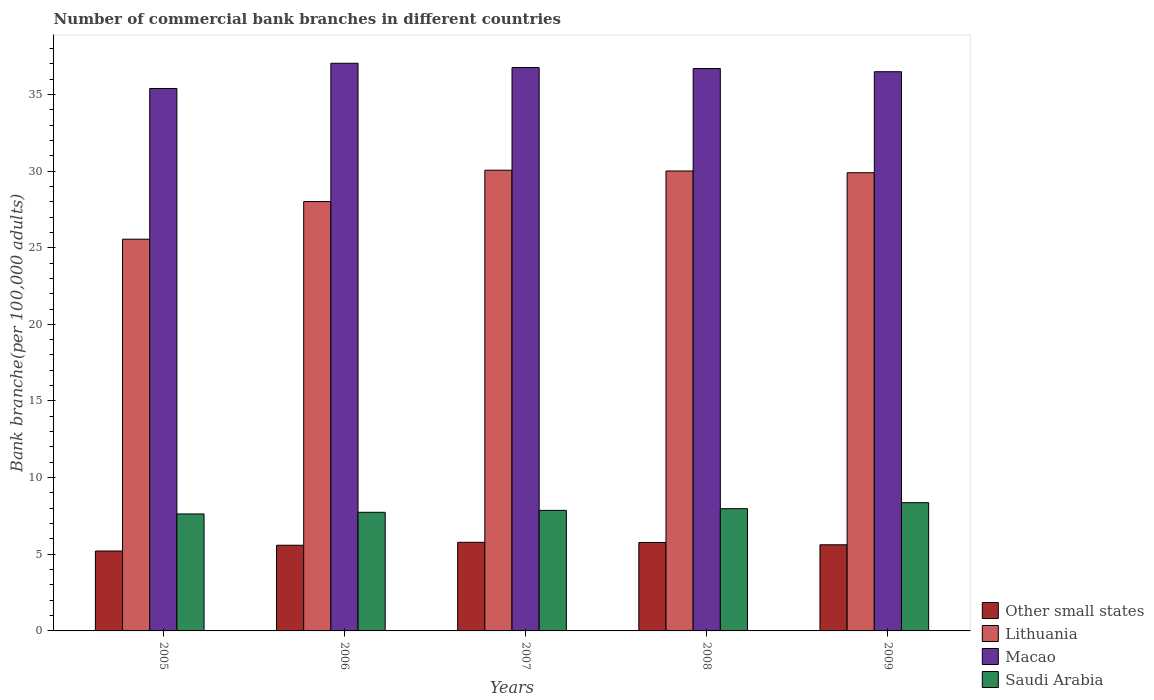How many different coloured bars are there?
Ensure brevity in your answer.  4. Are the number of bars per tick equal to the number of legend labels?
Offer a terse response. Yes. Are the number of bars on each tick of the X-axis equal?
Your response must be concise. Yes. How many bars are there on the 5th tick from the left?
Your response must be concise. 4. How many bars are there on the 1st tick from the right?
Ensure brevity in your answer.  4. What is the number of commercial bank branches in Lithuania in 2008?
Your response must be concise. 30. Across all years, what is the maximum number of commercial bank branches in Macao?
Make the answer very short. 37.03. Across all years, what is the minimum number of commercial bank branches in Saudi Arabia?
Offer a terse response. 7.63. In which year was the number of commercial bank branches in Lithuania maximum?
Your answer should be compact. 2007. In which year was the number of commercial bank branches in Other small states minimum?
Ensure brevity in your answer.  2005. What is the total number of commercial bank branches in Saudi Arabia in the graph?
Ensure brevity in your answer.  39.57. What is the difference between the number of commercial bank branches in Other small states in 2007 and that in 2008?
Ensure brevity in your answer.  0.01. What is the difference between the number of commercial bank branches in Other small states in 2005 and the number of commercial bank branches in Macao in 2009?
Your answer should be compact. -31.27. What is the average number of commercial bank branches in Other small states per year?
Offer a very short reply. 5.59. In the year 2005, what is the difference between the number of commercial bank branches in Other small states and number of commercial bank branches in Lithuania?
Make the answer very short. -20.34. In how many years, is the number of commercial bank branches in Saudi Arabia greater than 9?
Keep it short and to the point. 0. What is the ratio of the number of commercial bank branches in Saudi Arabia in 2006 to that in 2009?
Your answer should be very brief. 0.92. Is the difference between the number of commercial bank branches in Other small states in 2005 and 2009 greater than the difference between the number of commercial bank branches in Lithuania in 2005 and 2009?
Offer a terse response. Yes. What is the difference between the highest and the second highest number of commercial bank branches in Macao?
Keep it short and to the point. 0.28. What is the difference between the highest and the lowest number of commercial bank branches in Macao?
Keep it short and to the point. 1.65. In how many years, is the number of commercial bank branches in Saudi Arabia greater than the average number of commercial bank branches in Saudi Arabia taken over all years?
Ensure brevity in your answer.  2. What does the 1st bar from the left in 2009 represents?
Your answer should be very brief. Other small states. What does the 1st bar from the right in 2008 represents?
Offer a very short reply. Saudi Arabia. What is the difference between two consecutive major ticks on the Y-axis?
Provide a succinct answer. 5. Does the graph contain grids?
Make the answer very short. No. How many legend labels are there?
Provide a succinct answer. 4. How are the legend labels stacked?
Keep it short and to the point. Vertical. What is the title of the graph?
Provide a succinct answer. Number of commercial bank branches in different countries. What is the label or title of the X-axis?
Provide a succinct answer. Years. What is the label or title of the Y-axis?
Offer a terse response. Bank branche(per 100,0 adults). What is the Bank branche(per 100,000 adults) in Other small states in 2005?
Your answer should be very brief. 5.21. What is the Bank branche(per 100,000 adults) of Lithuania in 2005?
Your answer should be compact. 25.55. What is the Bank branche(per 100,000 adults) in Macao in 2005?
Offer a very short reply. 35.38. What is the Bank branche(per 100,000 adults) of Saudi Arabia in 2005?
Your answer should be very brief. 7.63. What is the Bank branche(per 100,000 adults) in Other small states in 2006?
Provide a succinct answer. 5.59. What is the Bank branche(per 100,000 adults) in Lithuania in 2006?
Provide a short and direct response. 28.01. What is the Bank branche(per 100,000 adults) in Macao in 2006?
Provide a short and direct response. 37.03. What is the Bank branche(per 100,000 adults) of Saudi Arabia in 2006?
Provide a succinct answer. 7.74. What is the Bank branche(per 100,000 adults) of Other small states in 2007?
Keep it short and to the point. 5.78. What is the Bank branche(per 100,000 adults) of Lithuania in 2007?
Offer a terse response. 30.05. What is the Bank branche(per 100,000 adults) of Macao in 2007?
Provide a succinct answer. 36.75. What is the Bank branche(per 100,000 adults) in Saudi Arabia in 2007?
Provide a succinct answer. 7.86. What is the Bank branche(per 100,000 adults) of Other small states in 2008?
Make the answer very short. 5.77. What is the Bank branche(per 100,000 adults) in Lithuania in 2008?
Your response must be concise. 30. What is the Bank branche(per 100,000 adults) in Macao in 2008?
Provide a succinct answer. 36.69. What is the Bank branche(per 100,000 adults) of Saudi Arabia in 2008?
Keep it short and to the point. 7.97. What is the Bank branche(per 100,000 adults) of Other small states in 2009?
Provide a short and direct response. 5.62. What is the Bank branche(per 100,000 adults) of Lithuania in 2009?
Offer a very short reply. 29.89. What is the Bank branche(per 100,000 adults) of Macao in 2009?
Provide a succinct answer. 36.48. What is the Bank branche(per 100,000 adults) of Saudi Arabia in 2009?
Provide a succinct answer. 8.37. Across all years, what is the maximum Bank branche(per 100,000 adults) of Other small states?
Offer a very short reply. 5.78. Across all years, what is the maximum Bank branche(per 100,000 adults) in Lithuania?
Your answer should be compact. 30.05. Across all years, what is the maximum Bank branche(per 100,000 adults) of Macao?
Ensure brevity in your answer.  37.03. Across all years, what is the maximum Bank branche(per 100,000 adults) of Saudi Arabia?
Offer a terse response. 8.37. Across all years, what is the minimum Bank branche(per 100,000 adults) in Other small states?
Your answer should be compact. 5.21. Across all years, what is the minimum Bank branche(per 100,000 adults) in Lithuania?
Offer a very short reply. 25.55. Across all years, what is the minimum Bank branche(per 100,000 adults) in Macao?
Keep it short and to the point. 35.38. Across all years, what is the minimum Bank branche(per 100,000 adults) in Saudi Arabia?
Offer a terse response. 7.63. What is the total Bank branche(per 100,000 adults) of Other small states in the graph?
Your response must be concise. 27.97. What is the total Bank branche(per 100,000 adults) in Lithuania in the graph?
Offer a terse response. 143.51. What is the total Bank branche(per 100,000 adults) in Macao in the graph?
Provide a short and direct response. 182.34. What is the total Bank branche(per 100,000 adults) of Saudi Arabia in the graph?
Your answer should be very brief. 39.57. What is the difference between the Bank branche(per 100,000 adults) in Other small states in 2005 and that in 2006?
Provide a short and direct response. -0.38. What is the difference between the Bank branche(per 100,000 adults) of Lithuania in 2005 and that in 2006?
Your answer should be very brief. -2.45. What is the difference between the Bank branche(per 100,000 adults) in Macao in 2005 and that in 2006?
Ensure brevity in your answer.  -1.65. What is the difference between the Bank branche(per 100,000 adults) of Saudi Arabia in 2005 and that in 2006?
Your answer should be compact. -0.11. What is the difference between the Bank branche(per 100,000 adults) of Other small states in 2005 and that in 2007?
Your answer should be very brief. -0.57. What is the difference between the Bank branche(per 100,000 adults) of Macao in 2005 and that in 2007?
Keep it short and to the point. -1.37. What is the difference between the Bank branche(per 100,000 adults) in Saudi Arabia in 2005 and that in 2007?
Provide a short and direct response. -0.23. What is the difference between the Bank branche(per 100,000 adults) of Other small states in 2005 and that in 2008?
Your answer should be very brief. -0.56. What is the difference between the Bank branche(per 100,000 adults) in Lithuania in 2005 and that in 2008?
Your answer should be very brief. -4.45. What is the difference between the Bank branche(per 100,000 adults) of Macao in 2005 and that in 2008?
Your response must be concise. -1.3. What is the difference between the Bank branche(per 100,000 adults) in Saudi Arabia in 2005 and that in 2008?
Keep it short and to the point. -0.34. What is the difference between the Bank branche(per 100,000 adults) of Other small states in 2005 and that in 2009?
Provide a short and direct response. -0.41. What is the difference between the Bank branche(per 100,000 adults) of Lithuania in 2005 and that in 2009?
Offer a very short reply. -4.34. What is the difference between the Bank branche(per 100,000 adults) in Macao in 2005 and that in 2009?
Your answer should be compact. -1.09. What is the difference between the Bank branche(per 100,000 adults) of Saudi Arabia in 2005 and that in 2009?
Your answer should be compact. -0.73. What is the difference between the Bank branche(per 100,000 adults) in Other small states in 2006 and that in 2007?
Make the answer very short. -0.19. What is the difference between the Bank branche(per 100,000 adults) of Lithuania in 2006 and that in 2007?
Provide a succinct answer. -2.05. What is the difference between the Bank branche(per 100,000 adults) of Macao in 2006 and that in 2007?
Ensure brevity in your answer.  0.28. What is the difference between the Bank branche(per 100,000 adults) in Saudi Arabia in 2006 and that in 2007?
Your answer should be very brief. -0.13. What is the difference between the Bank branche(per 100,000 adults) of Other small states in 2006 and that in 2008?
Ensure brevity in your answer.  -0.18. What is the difference between the Bank branche(per 100,000 adults) of Lithuania in 2006 and that in 2008?
Keep it short and to the point. -2. What is the difference between the Bank branche(per 100,000 adults) of Macao in 2006 and that in 2008?
Offer a terse response. 0.34. What is the difference between the Bank branche(per 100,000 adults) of Saudi Arabia in 2006 and that in 2008?
Offer a terse response. -0.24. What is the difference between the Bank branche(per 100,000 adults) of Other small states in 2006 and that in 2009?
Your answer should be very brief. -0.03. What is the difference between the Bank branche(per 100,000 adults) in Lithuania in 2006 and that in 2009?
Keep it short and to the point. -1.88. What is the difference between the Bank branche(per 100,000 adults) of Macao in 2006 and that in 2009?
Ensure brevity in your answer.  0.55. What is the difference between the Bank branche(per 100,000 adults) of Saudi Arabia in 2006 and that in 2009?
Keep it short and to the point. -0.63. What is the difference between the Bank branche(per 100,000 adults) of Other small states in 2007 and that in 2008?
Your answer should be very brief. 0.01. What is the difference between the Bank branche(per 100,000 adults) in Lithuania in 2007 and that in 2008?
Make the answer very short. 0.05. What is the difference between the Bank branche(per 100,000 adults) in Macao in 2007 and that in 2008?
Provide a short and direct response. 0.07. What is the difference between the Bank branche(per 100,000 adults) of Saudi Arabia in 2007 and that in 2008?
Keep it short and to the point. -0.11. What is the difference between the Bank branche(per 100,000 adults) in Other small states in 2007 and that in 2009?
Offer a terse response. 0.16. What is the difference between the Bank branche(per 100,000 adults) in Lithuania in 2007 and that in 2009?
Provide a short and direct response. 0.16. What is the difference between the Bank branche(per 100,000 adults) of Macao in 2007 and that in 2009?
Make the answer very short. 0.27. What is the difference between the Bank branche(per 100,000 adults) in Saudi Arabia in 2007 and that in 2009?
Ensure brevity in your answer.  -0.5. What is the difference between the Bank branche(per 100,000 adults) of Other small states in 2008 and that in 2009?
Your answer should be very brief. 0.15. What is the difference between the Bank branche(per 100,000 adults) in Lithuania in 2008 and that in 2009?
Your answer should be very brief. 0.11. What is the difference between the Bank branche(per 100,000 adults) in Macao in 2008 and that in 2009?
Provide a short and direct response. 0.21. What is the difference between the Bank branche(per 100,000 adults) in Saudi Arabia in 2008 and that in 2009?
Keep it short and to the point. -0.39. What is the difference between the Bank branche(per 100,000 adults) in Other small states in 2005 and the Bank branche(per 100,000 adults) in Lithuania in 2006?
Provide a succinct answer. -22.8. What is the difference between the Bank branche(per 100,000 adults) in Other small states in 2005 and the Bank branche(per 100,000 adults) in Macao in 2006?
Your response must be concise. -31.82. What is the difference between the Bank branche(per 100,000 adults) in Other small states in 2005 and the Bank branche(per 100,000 adults) in Saudi Arabia in 2006?
Provide a short and direct response. -2.53. What is the difference between the Bank branche(per 100,000 adults) in Lithuania in 2005 and the Bank branche(per 100,000 adults) in Macao in 2006?
Offer a very short reply. -11.48. What is the difference between the Bank branche(per 100,000 adults) of Lithuania in 2005 and the Bank branche(per 100,000 adults) of Saudi Arabia in 2006?
Give a very brief answer. 17.82. What is the difference between the Bank branche(per 100,000 adults) in Macao in 2005 and the Bank branche(per 100,000 adults) in Saudi Arabia in 2006?
Keep it short and to the point. 27.65. What is the difference between the Bank branche(per 100,000 adults) of Other small states in 2005 and the Bank branche(per 100,000 adults) of Lithuania in 2007?
Keep it short and to the point. -24.84. What is the difference between the Bank branche(per 100,000 adults) in Other small states in 2005 and the Bank branche(per 100,000 adults) in Macao in 2007?
Your answer should be compact. -31.54. What is the difference between the Bank branche(per 100,000 adults) in Other small states in 2005 and the Bank branche(per 100,000 adults) in Saudi Arabia in 2007?
Keep it short and to the point. -2.65. What is the difference between the Bank branche(per 100,000 adults) of Lithuania in 2005 and the Bank branche(per 100,000 adults) of Macao in 2007?
Offer a very short reply. -11.2. What is the difference between the Bank branche(per 100,000 adults) of Lithuania in 2005 and the Bank branche(per 100,000 adults) of Saudi Arabia in 2007?
Offer a very short reply. 17.69. What is the difference between the Bank branche(per 100,000 adults) in Macao in 2005 and the Bank branche(per 100,000 adults) in Saudi Arabia in 2007?
Your answer should be very brief. 27.52. What is the difference between the Bank branche(per 100,000 adults) in Other small states in 2005 and the Bank branche(per 100,000 adults) in Lithuania in 2008?
Your answer should be very brief. -24.79. What is the difference between the Bank branche(per 100,000 adults) of Other small states in 2005 and the Bank branche(per 100,000 adults) of Macao in 2008?
Provide a short and direct response. -31.48. What is the difference between the Bank branche(per 100,000 adults) in Other small states in 2005 and the Bank branche(per 100,000 adults) in Saudi Arabia in 2008?
Keep it short and to the point. -2.76. What is the difference between the Bank branche(per 100,000 adults) of Lithuania in 2005 and the Bank branche(per 100,000 adults) of Macao in 2008?
Give a very brief answer. -11.13. What is the difference between the Bank branche(per 100,000 adults) in Lithuania in 2005 and the Bank branche(per 100,000 adults) in Saudi Arabia in 2008?
Offer a terse response. 17.58. What is the difference between the Bank branche(per 100,000 adults) in Macao in 2005 and the Bank branche(per 100,000 adults) in Saudi Arabia in 2008?
Provide a succinct answer. 27.41. What is the difference between the Bank branche(per 100,000 adults) in Other small states in 2005 and the Bank branche(per 100,000 adults) in Lithuania in 2009?
Keep it short and to the point. -24.68. What is the difference between the Bank branche(per 100,000 adults) of Other small states in 2005 and the Bank branche(per 100,000 adults) of Macao in 2009?
Ensure brevity in your answer.  -31.27. What is the difference between the Bank branche(per 100,000 adults) of Other small states in 2005 and the Bank branche(per 100,000 adults) of Saudi Arabia in 2009?
Your answer should be compact. -3.15. What is the difference between the Bank branche(per 100,000 adults) in Lithuania in 2005 and the Bank branche(per 100,000 adults) in Macao in 2009?
Make the answer very short. -10.92. What is the difference between the Bank branche(per 100,000 adults) of Lithuania in 2005 and the Bank branche(per 100,000 adults) of Saudi Arabia in 2009?
Keep it short and to the point. 17.19. What is the difference between the Bank branche(per 100,000 adults) of Macao in 2005 and the Bank branche(per 100,000 adults) of Saudi Arabia in 2009?
Make the answer very short. 27.02. What is the difference between the Bank branche(per 100,000 adults) in Other small states in 2006 and the Bank branche(per 100,000 adults) in Lithuania in 2007?
Make the answer very short. -24.47. What is the difference between the Bank branche(per 100,000 adults) of Other small states in 2006 and the Bank branche(per 100,000 adults) of Macao in 2007?
Provide a succinct answer. -31.16. What is the difference between the Bank branche(per 100,000 adults) in Other small states in 2006 and the Bank branche(per 100,000 adults) in Saudi Arabia in 2007?
Your response must be concise. -2.27. What is the difference between the Bank branche(per 100,000 adults) of Lithuania in 2006 and the Bank branche(per 100,000 adults) of Macao in 2007?
Your answer should be very brief. -8.75. What is the difference between the Bank branche(per 100,000 adults) of Lithuania in 2006 and the Bank branche(per 100,000 adults) of Saudi Arabia in 2007?
Offer a very short reply. 20.14. What is the difference between the Bank branche(per 100,000 adults) in Macao in 2006 and the Bank branche(per 100,000 adults) in Saudi Arabia in 2007?
Give a very brief answer. 29.17. What is the difference between the Bank branche(per 100,000 adults) in Other small states in 2006 and the Bank branche(per 100,000 adults) in Lithuania in 2008?
Make the answer very short. -24.41. What is the difference between the Bank branche(per 100,000 adults) in Other small states in 2006 and the Bank branche(per 100,000 adults) in Macao in 2008?
Offer a very short reply. -31.1. What is the difference between the Bank branche(per 100,000 adults) in Other small states in 2006 and the Bank branche(per 100,000 adults) in Saudi Arabia in 2008?
Your answer should be very brief. -2.38. What is the difference between the Bank branche(per 100,000 adults) of Lithuania in 2006 and the Bank branche(per 100,000 adults) of Macao in 2008?
Your response must be concise. -8.68. What is the difference between the Bank branche(per 100,000 adults) of Lithuania in 2006 and the Bank branche(per 100,000 adults) of Saudi Arabia in 2008?
Offer a very short reply. 20.03. What is the difference between the Bank branche(per 100,000 adults) in Macao in 2006 and the Bank branche(per 100,000 adults) in Saudi Arabia in 2008?
Your answer should be very brief. 29.06. What is the difference between the Bank branche(per 100,000 adults) of Other small states in 2006 and the Bank branche(per 100,000 adults) of Lithuania in 2009?
Offer a terse response. -24.3. What is the difference between the Bank branche(per 100,000 adults) of Other small states in 2006 and the Bank branche(per 100,000 adults) of Macao in 2009?
Ensure brevity in your answer.  -30.89. What is the difference between the Bank branche(per 100,000 adults) in Other small states in 2006 and the Bank branche(per 100,000 adults) in Saudi Arabia in 2009?
Your response must be concise. -2.78. What is the difference between the Bank branche(per 100,000 adults) of Lithuania in 2006 and the Bank branche(per 100,000 adults) of Macao in 2009?
Make the answer very short. -8.47. What is the difference between the Bank branche(per 100,000 adults) in Lithuania in 2006 and the Bank branche(per 100,000 adults) in Saudi Arabia in 2009?
Keep it short and to the point. 19.64. What is the difference between the Bank branche(per 100,000 adults) of Macao in 2006 and the Bank branche(per 100,000 adults) of Saudi Arabia in 2009?
Provide a succinct answer. 28.67. What is the difference between the Bank branche(per 100,000 adults) in Other small states in 2007 and the Bank branche(per 100,000 adults) in Lithuania in 2008?
Provide a short and direct response. -24.22. What is the difference between the Bank branche(per 100,000 adults) in Other small states in 2007 and the Bank branche(per 100,000 adults) in Macao in 2008?
Provide a short and direct response. -30.91. What is the difference between the Bank branche(per 100,000 adults) of Other small states in 2007 and the Bank branche(per 100,000 adults) of Saudi Arabia in 2008?
Provide a succinct answer. -2.19. What is the difference between the Bank branche(per 100,000 adults) in Lithuania in 2007 and the Bank branche(per 100,000 adults) in Macao in 2008?
Offer a very short reply. -6.63. What is the difference between the Bank branche(per 100,000 adults) in Lithuania in 2007 and the Bank branche(per 100,000 adults) in Saudi Arabia in 2008?
Give a very brief answer. 22.08. What is the difference between the Bank branche(per 100,000 adults) of Macao in 2007 and the Bank branche(per 100,000 adults) of Saudi Arabia in 2008?
Give a very brief answer. 28.78. What is the difference between the Bank branche(per 100,000 adults) in Other small states in 2007 and the Bank branche(per 100,000 adults) in Lithuania in 2009?
Provide a short and direct response. -24.11. What is the difference between the Bank branche(per 100,000 adults) of Other small states in 2007 and the Bank branche(per 100,000 adults) of Macao in 2009?
Offer a very short reply. -30.7. What is the difference between the Bank branche(per 100,000 adults) in Other small states in 2007 and the Bank branche(per 100,000 adults) in Saudi Arabia in 2009?
Offer a very short reply. -2.59. What is the difference between the Bank branche(per 100,000 adults) in Lithuania in 2007 and the Bank branche(per 100,000 adults) in Macao in 2009?
Offer a very short reply. -6.42. What is the difference between the Bank branche(per 100,000 adults) in Lithuania in 2007 and the Bank branche(per 100,000 adults) in Saudi Arabia in 2009?
Provide a short and direct response. 21.69. What is the difference between the Bank branche(per 100,000 adults) in Macao in 2007 and the Bank branche(per 100,000 adults) in Saudi Arabia in 2009?
Keep it short and to the point. 28.39. What is the difference between the Bank branche(per 100,000 adults) of Other small states in 2008 and the Bank branche(per 100,000 adults) of Lithuania in 2009?
Offer a very short reply. -24.12. What is the difference between the Bank branche(per 100,000 adults) of Other small states in 2008 and the Bank branche(per 100,000 adults) of Macao in 2009?
Provide a short and direct response. -30.71. What is the difference between the Bank branche(per 100,000 adults) of Other small states in 2008 and the Bank branche(per 100,000 adults) of Saudi Arabia in 2009?
Ensure brevity in your answer.  -2.6. What is the difference between the Bank branche(per 100,000 adults) in Lithuania in 2008 and the Bank branche(per 100,000 adults) in Macao in 2009?
Ensure brevity in your answer.  -6.48. What is the difference between the Bank branche(per 100,000 adults) of Lithuania in 2008 and the Bank branche(per 100,000 adults) of Saudi Arabia in 2009?
Ensure brevity in your answer.  21.64. What is the difference between the Bank branche(per 100,000 adults) of Macao in 2008 and the Bank branche(per 100,000 adults) of Saudi Arabia in 2009?
Your response must be concise. 28.32. What is the average Bank branche(per 100,000 adults) of Other small states per year?
Your response must be concise. 5.59. What is the average Bank branche(per 100,000 adults) of Lithuania per year?
Your answer should be very brief. 28.7. What is the average Bank branche(per 100,000 adults) in Macao per year?
Offer a terse response. 36.47. What is the average Bank branche(per 100,000 adults) of Saudi Arabia per year?
Provide a short and direct response. 7.91. In the year 2005, what is the difference between the Bank branche(per 100,000 adults) in Other small states and Bank branche(per 100,000 adults) in Lithuania?
Provide a succinct answer. -20.34. In the year 2005, what is the difference between the Bank branche(per 100,000 adults) in Other small states and Bank branche(per 100,000 adults) in Macao?
Offer a terse response. -30.17. In the year 2005, what is the difference between the Bank branche(per 100,000 adults) of Other small states and Bank branche(per 100,000 adults) of Saudi Arabia?
Offer a terse response. -2.42. In the year 2005, what is the difference between the Bank branche(per 100,000 adults) of Lithuania and Bank branche(per 100,000 adults) of Macao?
Give a very brief answer. -9.83. In the year 2005, what is the difference between the Bank branche(per 100,000 adults) in Lithuania and Bank branche(per 100,000 adults) in Saudi Arabia?
Ensure brevity in your answer.  17.92. In the year 2005, what is the difference between the Bank branche(per 100,000 adults) in Macao and Bank branche(per 100,000 adults) in Saudi Arabia?
Your answer should be very brief. 27.75. In the year 2006, what is the difference between the Bank branche(per 100,000 adults) in Other small states and Bank branche(per 100,000 adults) in Lithuania?
Your response must be concise. -22.42. In the year 2006, what is the difference between the Bank branche(per 100,000 adults) of Other small states and Bank branche(per 100,000 adults) of Macao?
Provide a short and direct response. -31.44. In the year 2006, what is the difference between the Bank branche(per 100,000 adults) of Other small states and Bank branche(per 100,000 adults) of Saudi Arabia?
Your answer should be very brief. -2.15. In the year 2006, what is the difference between the Bank branche(per 100,000 adults) in Lithuania and Bank branche(per 100,000 adults) in Macao?
Ensure brevity in your answer.  -9.02. In the year 2006, what is the difference between the Bank branche(per 100,000 adults) in Lithuania and Bank branche(per 100,000 adults) in Saudi Arabia?
Your answer should be compact. 20.27. In the year 2006, what is the difference between the Bank branche(per 100,000 adults) of Macao and Bank branche(per 100,000 adults) of Saudi Arabia?
Your answer should be compact. 29.29. In the year 2007, what is the difference between the Bank branche(per 100,000 adults) in Other small states and Bank branche(per 100,000 adults) in Lithuania?
Your response must be concise. -24.27. In the year 2007, what is the difference between the Bank branche(per 100,000 adults) in Other small states and Bank branche(per 100,000 adults) in Macao?
Your answer should be very brief. -30.97. In the year 2007, what is the difference between the Bank branche(per 100,000 adults) of Other small states and Bank branche(per 100,000 adults) of Saudi Arabia?
Offer a terse response. -2.08. In the year 2007, what is the difference between the Bank branche(per 100,000 adults) of Lithuania and Bank branche(per 100,000 adults) of Macao?
Your answer should be very brief. -6.7. In the year 2007, what is the difference between the Bank branche(per 100,000 adults) in Lithuania and Bank branche(per 100,000 adults) in Saudi Arabia?
Provide a short and direct response. 22.19. In the year 2007, what is the difference between the Bank branche(per 100,000 adults) of Macao and Bank branche(per 100,000 adults) of Saudi Arabia?
Your answer should be compact. 28.89. In the year 2008, what is the difference between the Bank branche(per 100,000 adults) in Other small states and Bank branche(per 100,000 adults) in Lithuania?
Offer a very short reply. -24.23. In the year 2008, what is the difference between the Bank branche(per 100,000 adults) in Other small states and Bank branche(per 100,000 adults) in Macao?
Your response must be concise. -30.92. In the year 2008, what is the difference between the Bank branche(per 100,000 adults) in Other small states and Bank branche(per 100,000 adults) in Saudi Arabia?
Give a very brief answer. -2.2. In the year 2008, what is the difference between the Bank branche(per 100,000 adults) of Lithuania and Bank branche(per 100,000 adults) of Macao?
Your answer should be very brief. -6.68. In the year 2008, what is the difference between the Bank branche(per 100,000 adults) of Lithuania and Bank branche(per 100,000 adults) of Saudi Arabia?
Keep it short and to the point. 22.03. In the year 2008, what is the difference between the Bank branche(per 100,000 adults) of Macao and Bank branche(per 100,000 adults) of Saudi Arabia?
Provide a succinct answer. 28.71. In the year 2009, what is the difference between the Bank branche(per 100,000 adults) of Other small states and Bank branche(per 100,000 adults) of Lithuania?
Keep it short and to the point. -24.27. In the year 2009, what is the difference between the Bank branche(per 100,000 adults) in Other small states and Bank branche(per 100,000 adults) in Macao?
Make the answer very short. -30.86. In the year 2009, what is the difference between the Bank branche(per 100,000 adults) of Other small states and Bank branche(per 100,000 adults) of Saudi Arabia?
Keep it short and to the point. -2.75. In the year 2009, what is the difference between the Bank branche(per 100,000 adults) in Lithuania and Bank branche(per 100,000 adults) in Macao?
Keep it short and to the point. -6.59. In the year 2009, what is the difference between the Bank branche(per 100,000 adults) of Lithuania and Bank branche(per 100,000 adults) of Saudi Arabia?
Offer a very short reply. 21.52. In the year 2009, what is the difference between the Bank branche(per 100,000 adults) in Macao and Bank branche(per 100,000 adults) in Saudi Arabia?
Make the answer very short. 28.11. What is the ratio of the Bank branche(per 100,000 adults) in Other small states in 2005 to that in 2006?
Your answer should be compact. 0.93. What is the ratio of the Bank branche(per 100,000 adults) of Lithuania in 2005 to that in 2006?
Offer a terse response. 0.91. What is the ratio of the Bank branche(per 100,000 adults) in Macao in 2005 to that in 2006?
Make the answer very short. 0.96. What is the ratio of the Bank branche(per 100,000 adults) in Saudi Arabia in 2005 to that in 2006?
Ensure brevity in your answer.  0.99. What is the ratio of the Bank branche(per 100,000 adults) in Other small states in 2005 to that in 2007?
Give a very brief answer. 0.9. What is the ratio of the Bank branche(per 100,000 adults) of Lithuania in 2005 to that in 2007?
Offer a terse response. 0.85. What is the ratio of the Bank branche(per 100,000 adults) in Macao in 2005 to that in 2007?
Offer a terse response. 0.96. What is the ratio of the Bank branche(per 100,000 adults) in Saudi Arabia in 2005 to that in 2007?
Your answer should be compact. 0.97. What is the ratio of the Bank branche(per 100,000 adults) in Other small states in 2005 to that in 2008?
Ensure brevity in your answer.  0.9. What is the ratio of the Bank branche(per 100,000 adults) of Lithuania in 2005 to that in 2008?
Your response must be concise. 0.85. What is the ratio of the Bank branche(per 100,000 adults) of Macao in 2005 to that in 2008?
Offer a very short reply. 0.96. What is the ratio of the Bank branche(per 100,000 adults) in Saudi Arabia in 2005 to that in 2008?
Your response must be concise. 0.96. What is the ratio of the Bank branche(per 100,000 adults) in Other small states in 2005 to that in 2009?
Your answer should be compact. 0.93. What is the ratio of the Bank branche(per 100,000 adults) of Lithuania in 2005 to that in 2009?
Keep it short and to the point. 0.85. What is the ratio of the Bank branche(per 100,000 adults) in Macao in 2005 to that in 2009?
Keep it short and to the point. 0.97. What is the ratio of the Bank branche(per 100,000 adults) in Saudi Arabia in 2005 to that in 2009?
Give a very brief answer. 0.91. What is the ratio of the Bank branche(per 100,000 adults) in Other small states in 2006 to that in 2007?
Make the answer very short. 0.97. What is the ratio of the Bank branche(per 100,000 adults) in Lithuania in 2006 to that in 2007?
Provide a succinct answer. 0.93. What is the ratio of the Bank branche(per 100,000 adults) in Macao in 2006 to that in 2007?
Make the answer very short. 1.01. What is the ratio of the Bank branche(per 100,000 adults) in Other small states in 2006 to that in 2008?
Ensure brevity in your answer.  0.97. What is the ratio of the Bank branche(per 100,000 adults) in Lithuania in 2006 to that in 2008?
Give a very brief answer. 0.93. What is the ratio of the Bank branche(per 100,000 adults) in Macao in 2006 to that in 2008?
Your answer should be very brief. 1.01. What is the ratio of the Bank branche(per 100,000 adults) in Saudi Arabia in 2006 to that in 2008?
Provide a succinct answer. 0.97. What is the ratio of the Bank branche(per 100,000 adults) in Other small states in 2006 to that in 2009?
Your answer should be compact. 0.99. What is the ratio of the Bank branche(per 100,000 adults) in Lithuania in 2006 to that in 2009?
Provide a succinct answer. 0.94. What is the ratio of the Bank branche(per 100,000 adults) in Macao in 2006 to that in 2009?
Give a very brief answer. 1.02. What is the ratio of the Bank branche(per 100,000 adults) in Saudi Arabia in 2006 to that in 2009?
Provide a succinct answer. 0.92. What is the ratio of the Bank branche(per 100,000 adults) of Other small states in 2007 to that in 2008?
Keep it short and to the point. 1. What is the ratio of the Bank branche(per 100,000 adults) in Lithuania in 2007 to that in 2008?
Provide a succinct answer. 1. What is the ratio of the Bank branche(per 100,000 adults) in Saudi Arabia in 2007 to that in 2008?
Your answer should be compact. 0.99. What is the ratio of the Bank branche(per 100,000 adults) of Other small states in 2007 to that in 2009?
Make the answer very short. 1.03. What is the ratio of the Bank branche(per 100,000 adults) in Macao in 2007 to that in 2009?
Offer a terse response. 1.01. What is the ratio of the Bank branche(per 100,000 adults) of Saudi Arabia in 2007 to that in 2009?
Provide a short and direct response. 0.94. What is the ratio of the Bank branche(per 100,000 adults) in Other small states in 2008 to that in 2009?
Ensure brevity in your answer.  1.03. What is the ratio of the Bank branche(per 100,000 adults) of Lithuania in 2008 to that in 2009?
Offer a terse response. 1. What is the ratio of the Bank branche(per 100,000 adults) in Saudi Arabia in 2008 to that in 2009?
Your response must be concise. 0.95. What is the difference between the highest and the second highest Bank branche(per 100,000 adults) of Other small states?
Offer a terse response. 0.01. What is the difference between the highest and the second highest Bank branche(per 100,000 adults) of Lithuania?
Provide a short and direct response. 0.05. What is the difference between the highest and the second highest Bank branche(per 100,000 adults) in Macao?
Make the answer very short. 0.28. What is the difference between the highest and the second highest Bank branche(per 100,000 adults) in Saudi Arabia?
Provide a succinct answer. 0.39. What is the difference between the highest and the lowest Bank branche(per 100,000 adults) in Other small states?
Your answer should be compact. 0.57. What is the difference between the highest and the lowest Bank branche(per 100,000 adults) in Lithuania?
Give a very brief answer. 4.5. What is the difference between the highest and the lowest Bank branche(per 100,000 adults) of Macao?
Offer a very short reply. 1.65. What is the difference between the highest and the lowest Bank branche(per 100,000 adults) of Saudi Arabia?
Your answer should be very brief. 0.73. 